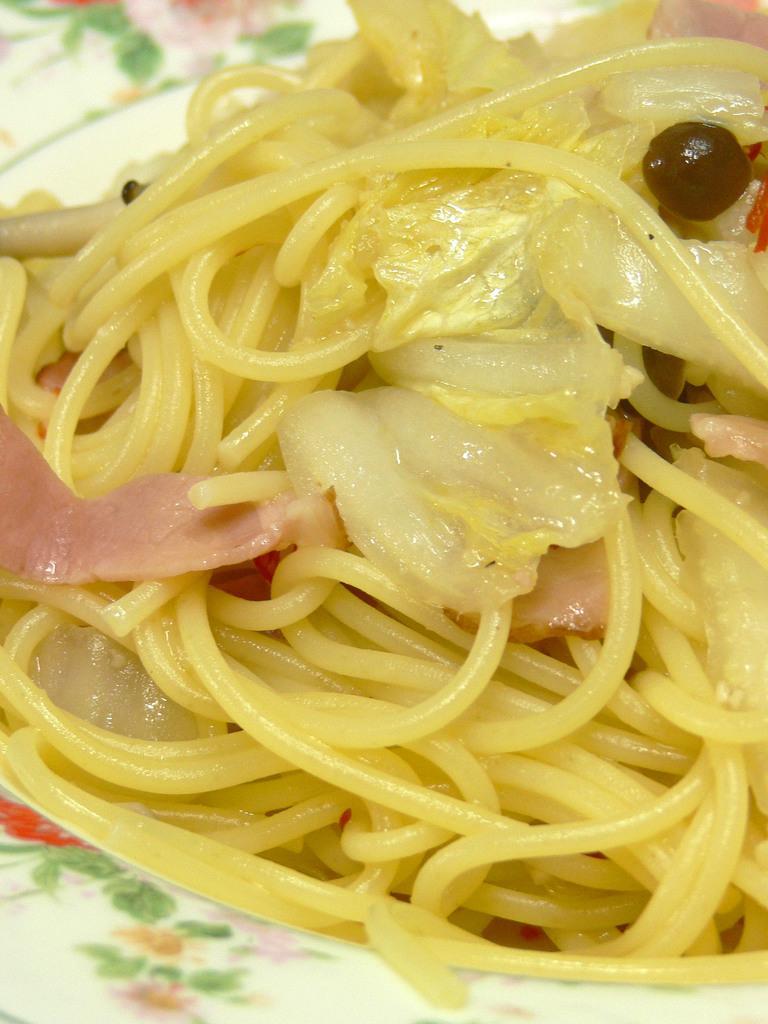In one or two sentences, can you explain what this image depicts? In this image there is a plate, and in the plate there are noodles. 